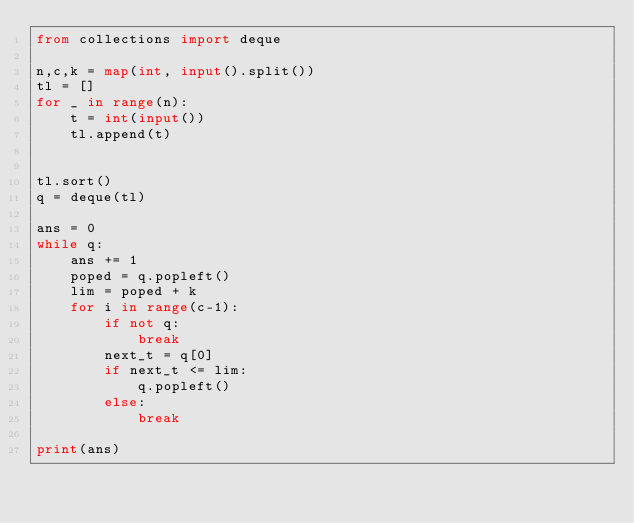<code> <loc_0><loc_0><loc_500><loc_500><_Python_>from collections import deque

n,c,k = map(int, input().split())
tl = []
for _ in range(n):
    t = int(input())
    tl.append(t)


tl.sort()
q = deque(tl)

ans = 0
while q:
    ans += 1
    poped = q.popleft()
    lim = poped + k
    for i in range(c-1):
        if not q:
            break
        next_t = q[0]
        if next_t <= lim:
            q.popleft()
        else:
            break

print(ans)</code> 